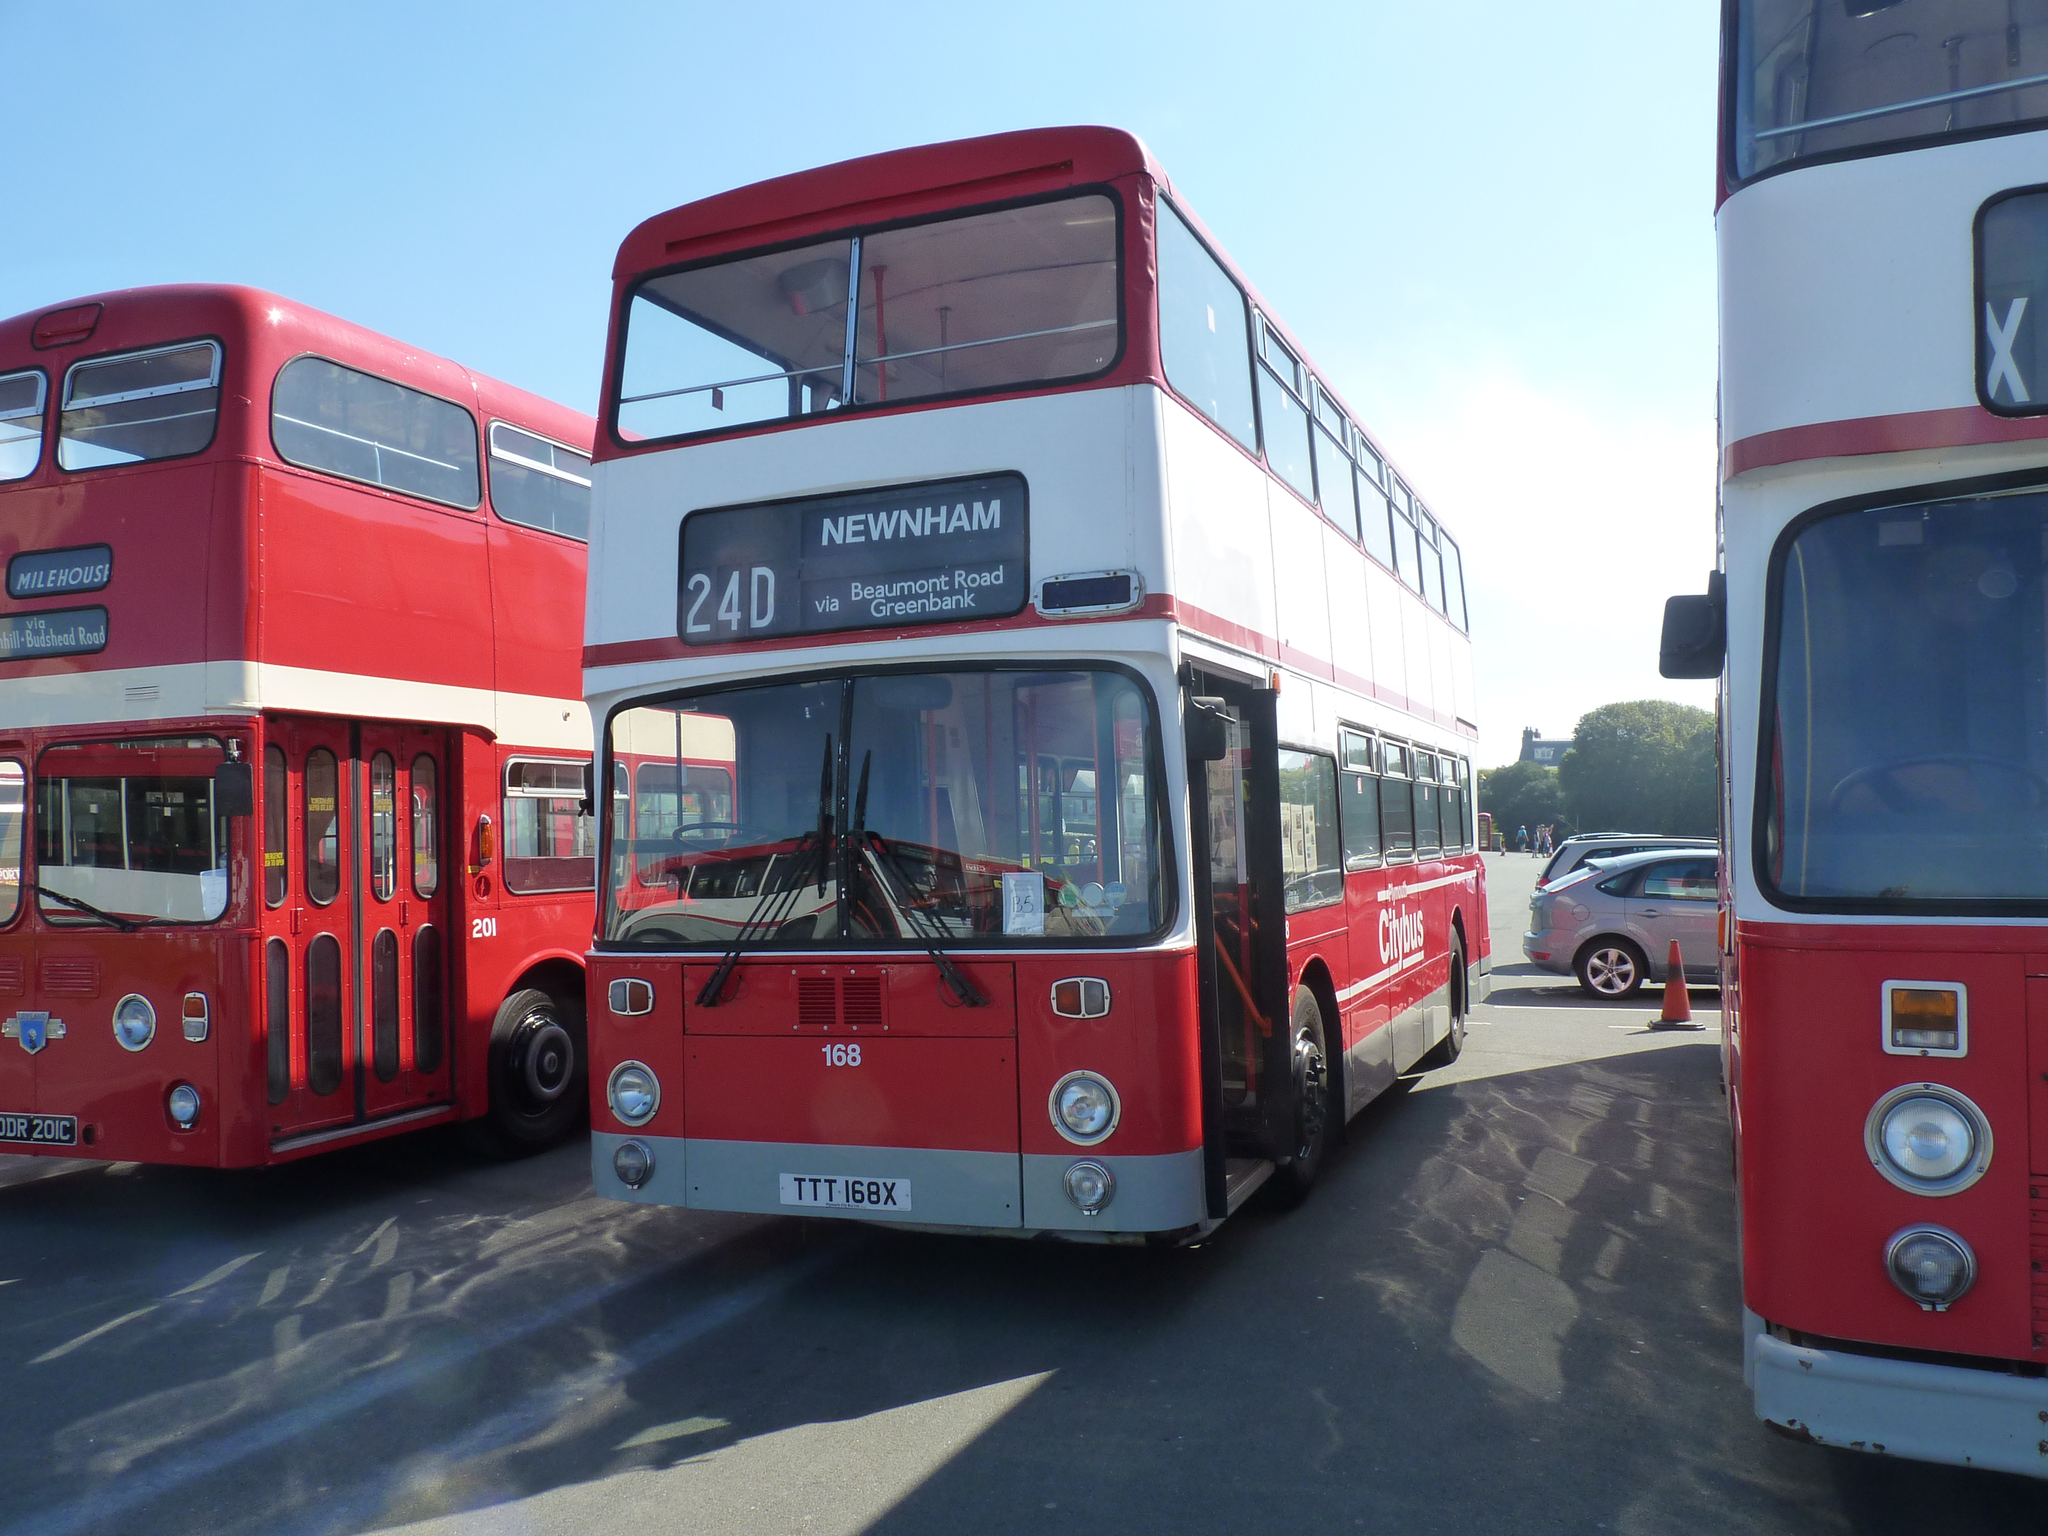Where is the middle bus going?
Make the answer very short. Newnham. 